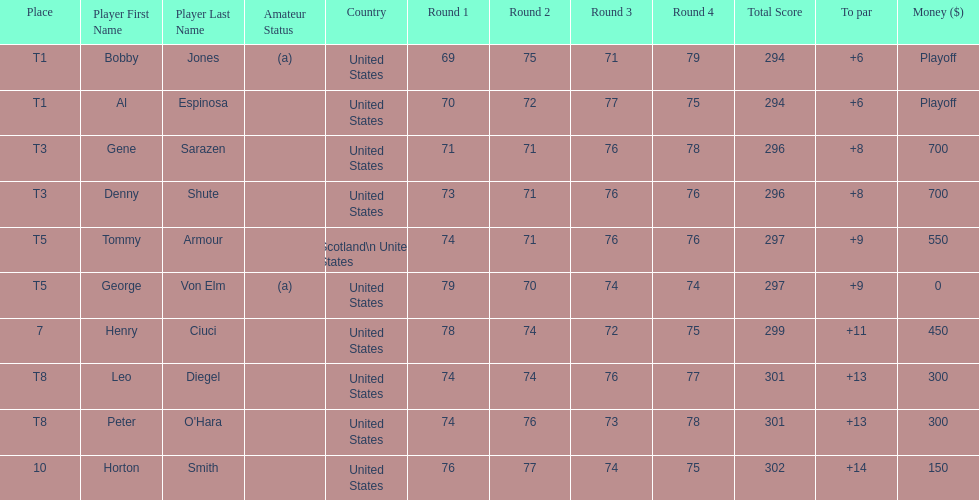What was al espinosa's total stroke count at the final of the 1929 us open? 294. 